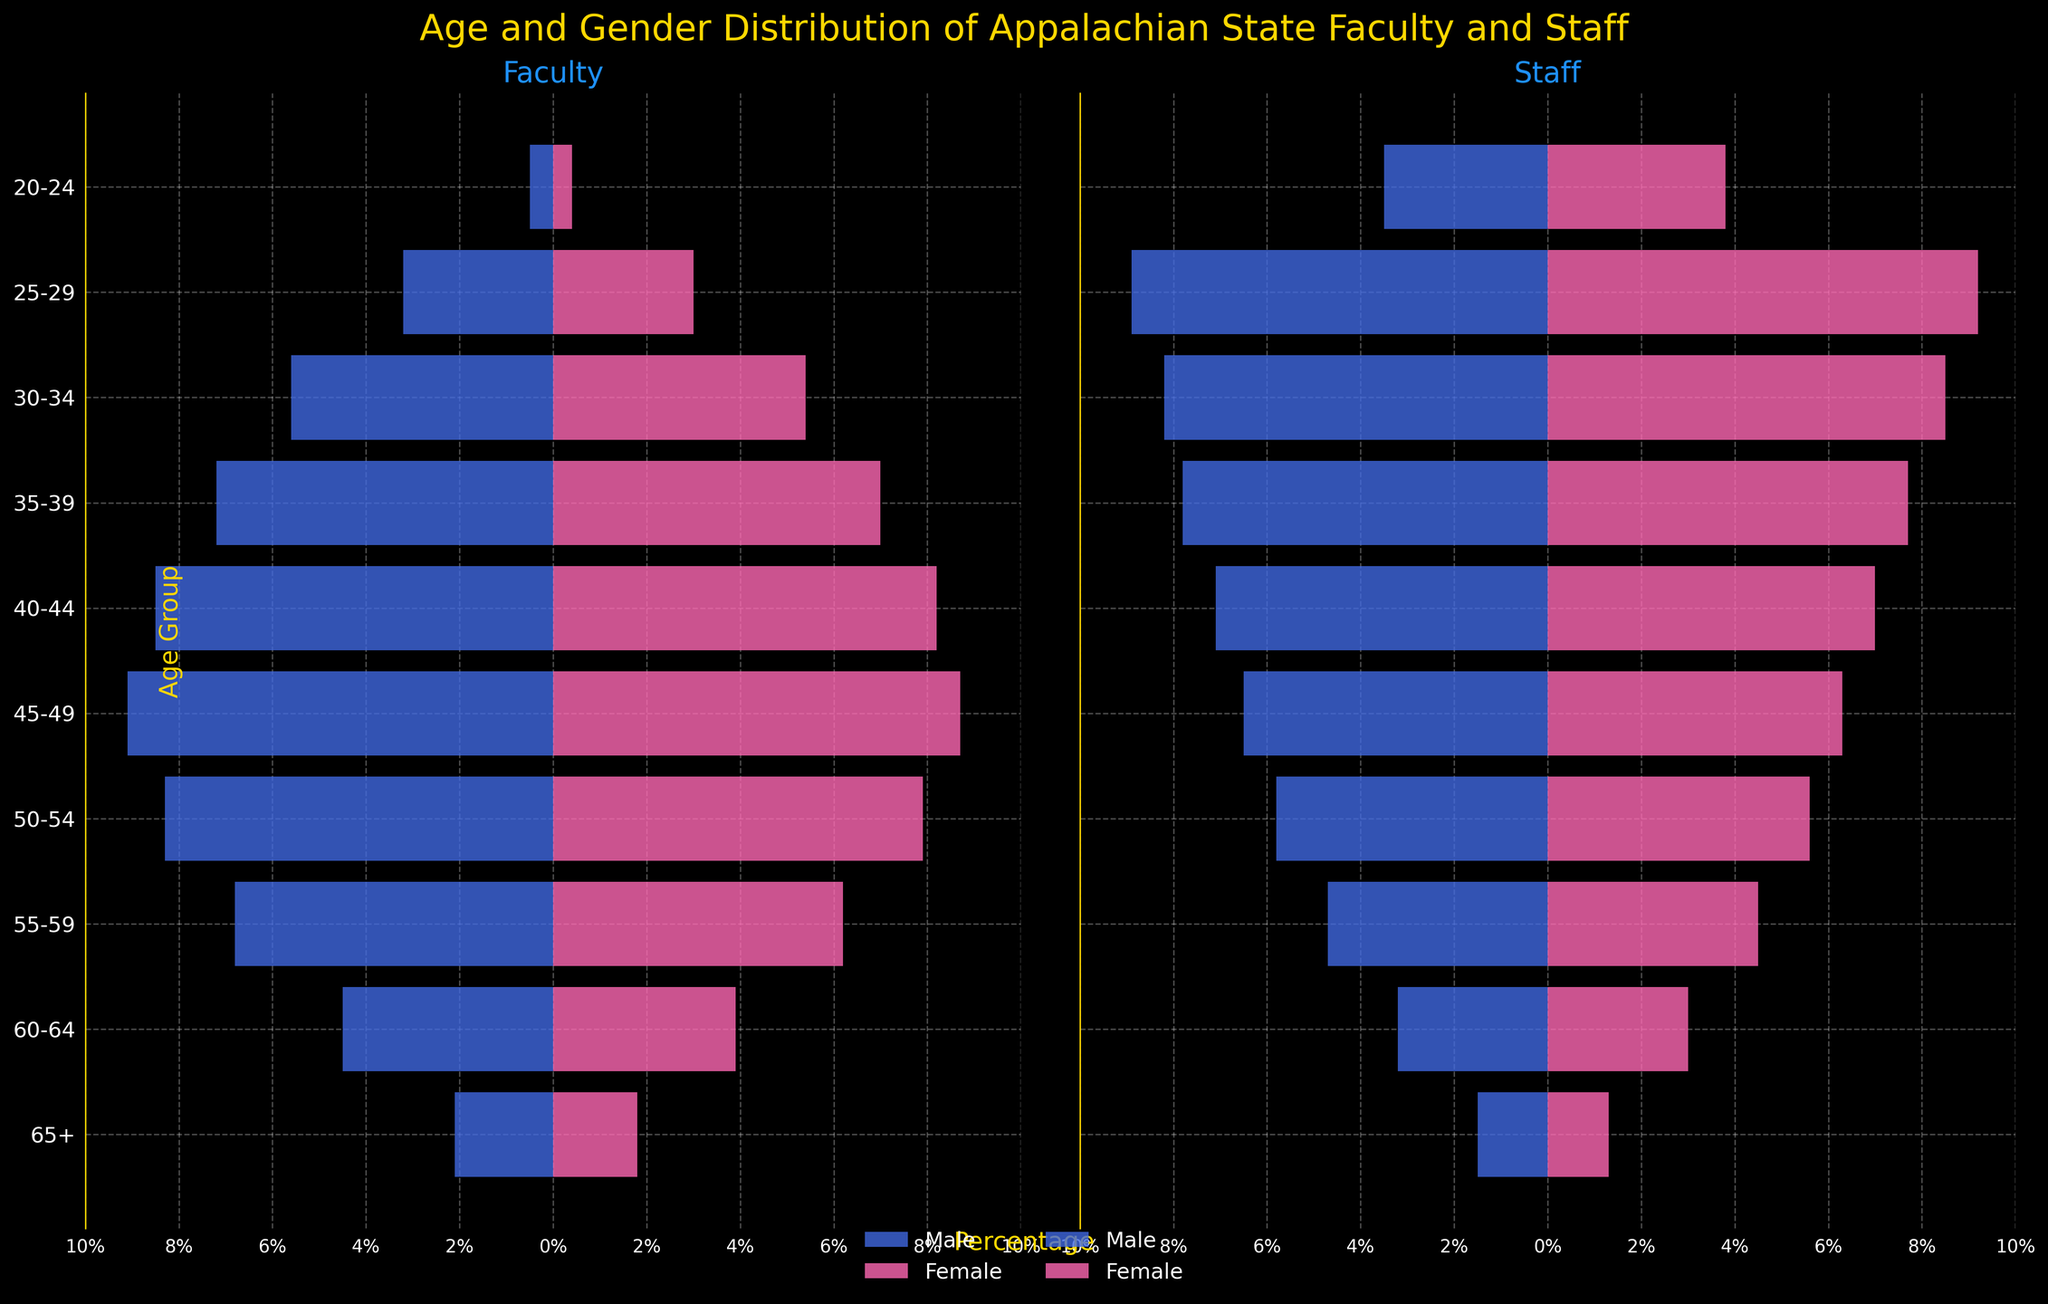What is the title of the figure? The title of the figure is typically found at the top or the central part of the chart. In this plot, it is located at the top center.
Answer: Age and Gender Distribution of Appalachian State Faculty and Staff How are the male and female faculty percentages visually represented in the plot? Each age group has a bar with two parts: one part represents male faculty percentages on the left side in blue, and the other part represents female faculty percentages on the right side in pink.
Answer: Blue for males and Pink for females Which age group has the highest percentage of male faculty? To find the highest percentage of male faculty, scan the bars on the left side for each age group and identify the age group with the longest blue bar. The 45-49 age group has the longest blue bar.
Answer: 45-49 For staff, which gender has larger representation percentages in the 25-29 age group? To compare the percentages, observe the lengths of the blue bar (male staff) and pink bar (female staff) for the 25-29 age group on the right side. The pink bar is longer than the blue bar.
Answer: Female staff What is the total percentage of male and female faculty in the 60-64 age group? To find the total, add the percentages of male and female faculty for the 60-64 age group: 4.5% (male) + 3.9% (female) = 8.4%.
Answer: 8.4% How does the percentage of male and female staff in the 30-34 age group compare with each other? Compare the length of the blue bar (male staff) and the pink bar (female staff) in the 30-34 age group on the right side; the pink bar is slightly longer than the blue bar.
Answer: Female staff is larger In which age group is the gender distribution among staff closest to equal? To determine the age group with the closest to equal gender distribution among staff, find the age group where the blue and pink bars have nearly equal lengths. The 35-39 age group has the closest to equal lengths.
Answer: 35-39 What is the percentage difference between male and female staff in the 20-24 age group? To find the percentage difference, subtract the percentages of male and female staff in the 20-24 age group: 3.8% (female) - 3.5% (male) = 0.3%.
Answer: 0.3% How does the age distribution between faculty and staff differ in the older age groups (55+) for males? To compare, observe the lengths of the blue bars for males in age groups 55-59, 60-64, and 65+ for both faculty (left) and staff (right). Faculty have higher percentages in 55+ age groups compared to staff.
Answer: Higher percentages for faculty 